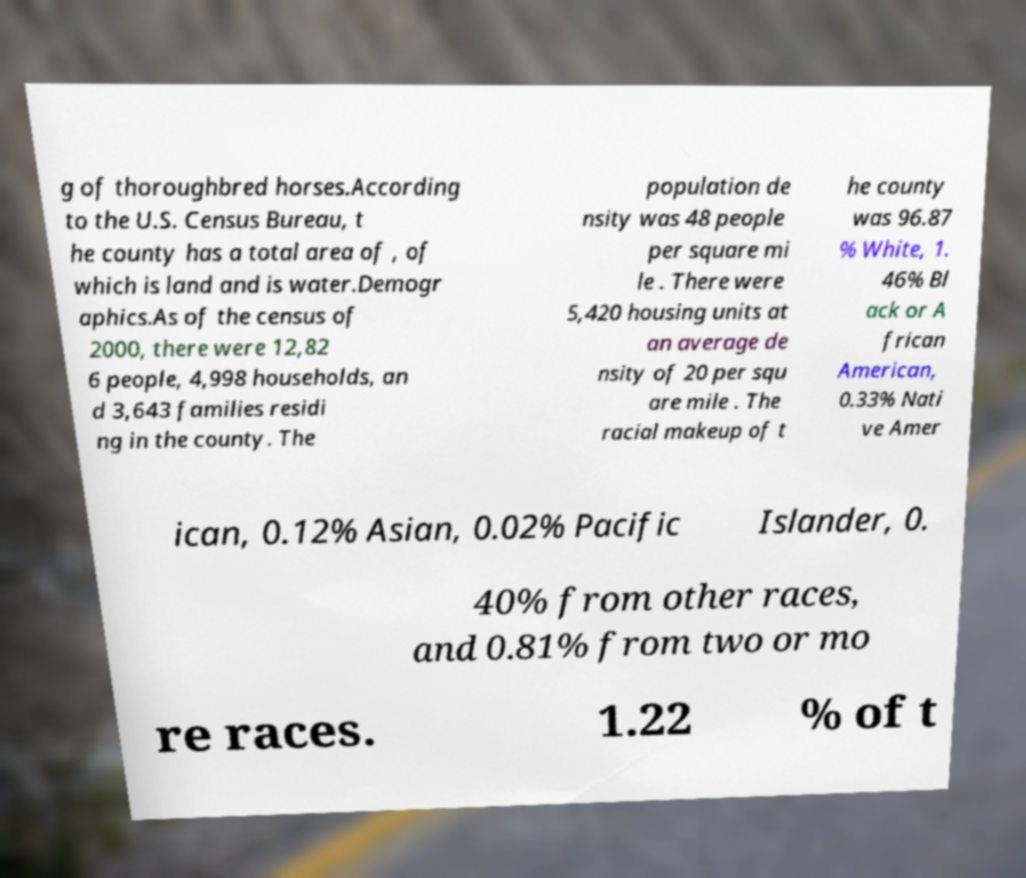I need the written content from this picture converted into text. Can you do that? g of thoroughbred horses.According to the U.S. Census Bureau, t he county has a total area of , of which is land and is water.Demogr aphics.As of the census of 2000, there were 12,82 6 people, 4,998 households, an d 3,643 families residi ng in the county. The population de nsity was 48 people per square mi le . There were 5,420 housing units at an average de nsity of 20 per squ are mile . The racial makeup of t he county was 96.87 % White, 1. 46% Bl ack or A frican American, 0.33% Nati ve Amer ican, 0.12% Asian, 0.02% Pacific Islander, 0. 40% from other races, and 0.81% from two or mo re races. 1.22 % of t 